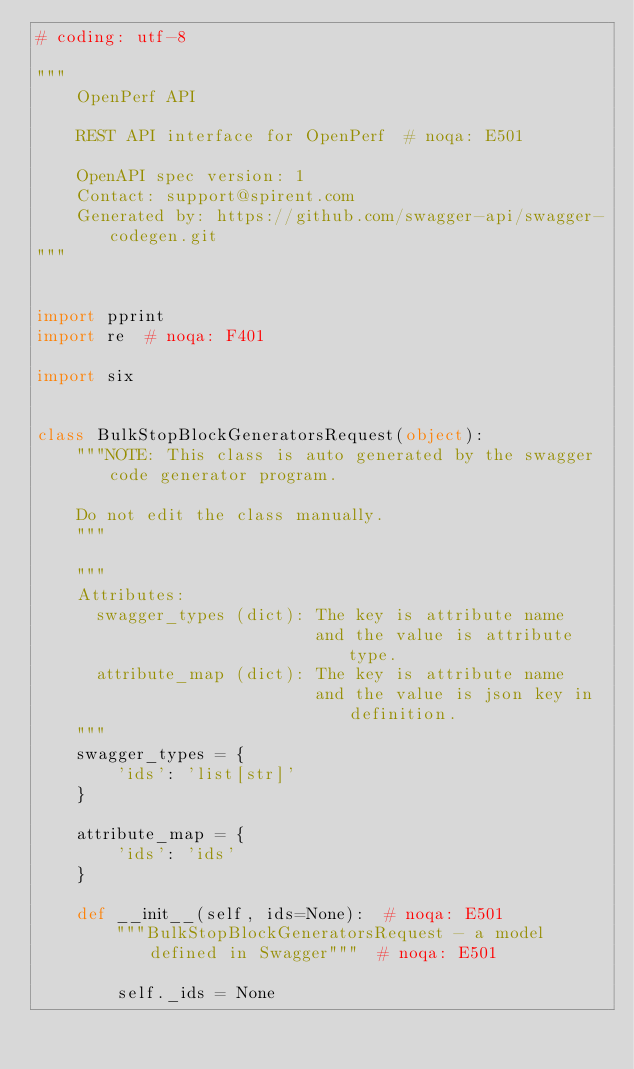<code> <loc_0><loc_0><loc_500><loc_500><_Python_># coding: utf-8

"""
    OpenPerf API

    REST API interface for OpenPerf  # noqa: E501

    OpenAPI spec version: 1
    Contact: support@spirent.com
    Generated by: https://github.com/swagger-api/swagger-codegen.git
"""


import pprint
import re  # noqa: F401

import six


class BulkStopBlockGeneratorsRequest(object):
    """NOTE: This class is auto generated by the swagger code generator program.

    Do not edit the class manually.
    """

    """
    Attributes:
      swagger_types (dict): The key is attribute name
                            and the value is attribute type.
      attribute_map (dict): The key is attribute name
                            and the value is json key in definition.
    """
    swagger_types = {
        'ids': 'list[str]'
    }

    attribute_map = {
        'ids': 'ids'
    }

    def __init__(self, ids=None):  # noqa: E501
        """BulkStopBlockGeneratorsRequest - a model defined in Swagger"""  # noqa: E501

        self._ids = None</code> 